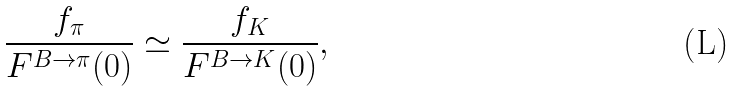Convert formula to latex. <formula><loc_0><loc_0><loc_500><loc_500>\frac { f _ { \pi } } { F ^ { B \to \pi } ( 0 ) } \simeq \frac { f _ { K } } { F ^ { B \to K } ( 0 ) } ,</formula> 